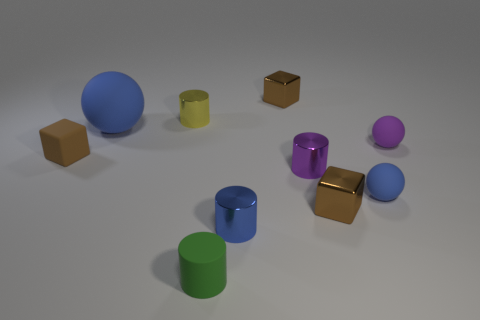How many brown cubes must be subtracted to get 1 brown cubes? 2 Subtract all cylinders. How many objects are left? 6 Add 1 green objects. How many green objects are left? 2 Add 8 large brown metal cubes. How many large brown metal cubes exist? 8 Subtract 1 purple spheres. How many objects are left? 9 Subtract all purple metal objects. Subtract all big purple metal blocks. How many objects are left? 9 